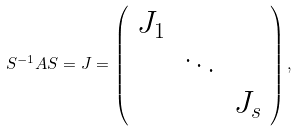Convert formula to latex. <formula><loc_0><loc_0><loc_500><loc_500>S ^ { - 1 } A S = J = \left ( \begin{array} { c c c } J _ { 1 } & & \\ & \ddots & \\ & & J _ { s } \end{array} \right ) ,</formula> 